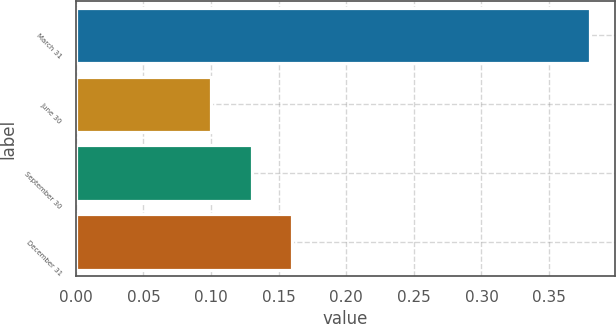Convert chart. <chart><loc_0><loc_0><loc_500><loc_500><bar_chart><fcel>March 31<fcel>June 30<fcel>September 30<fcel>December 31<nl><fcel>0.38<fcel>0.1<fcel>0.13<fcel>0.16<nl></chart> 